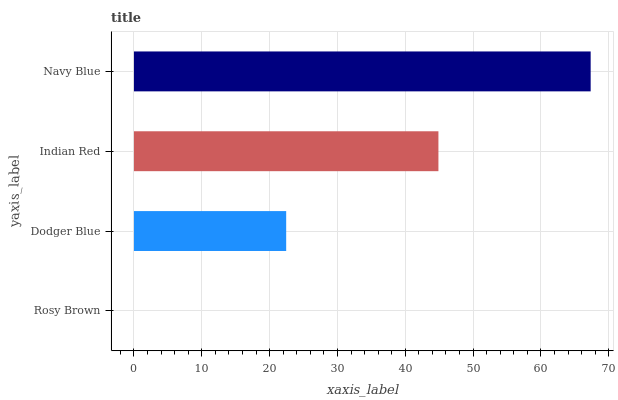Is Rosy Brown the minimum?
Answer yes or no. Yes. Is Navy Blue the maximum?
Answer yes or no. Yes. Is Dodger Blue the minimum?
Answer yes or no. No. Is Dodger Blue the maximum?
Answer yes or no. No. Is Dodger Blue greater than Rosy Brown?
Answer yes or no. Yes. Is Rosy Brown less than Dodger Blue?
Answer yes or no. Yes. Is Rosy Brown greater than Dodger Blue?
Answer yes or no. No. Is Dodger Blue less than Rosy Brown?
Answer yes or no. No. Is Indian Red the high median?
Answer yes or no. Yes. Is Dodger Blue the low median?
Answer yes or no. Yes. Is Navy Blue the high median?
Answer yes or no. No. Is Navy Blue the low median?
Answer yes or no. No. 